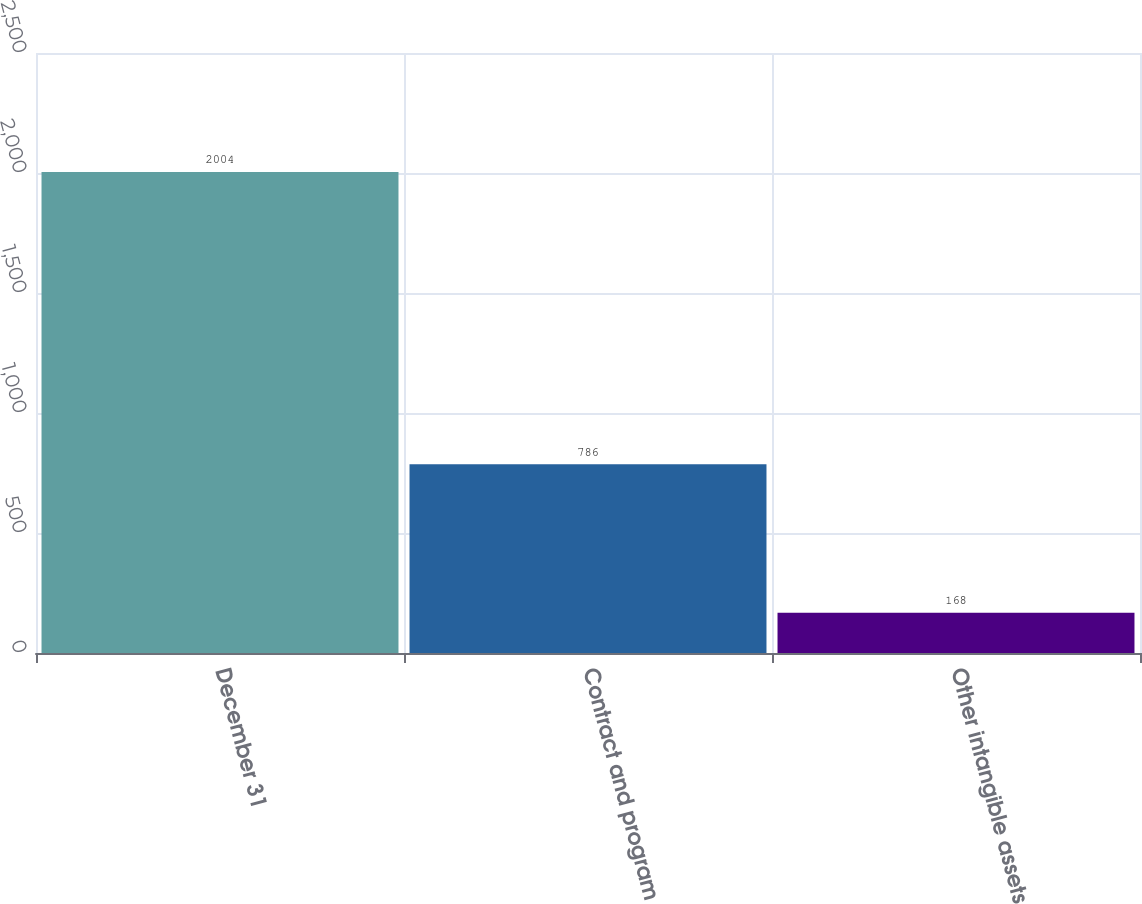Convert chart. <chart><loc_0><loc_0><loc_500><loc_500><bar_chart><fcel>December 31<fcel>Contract and program<fcel>Other intangible assets<nl><fcel>2004<fcel>786<fcel>168<nl></chart> 